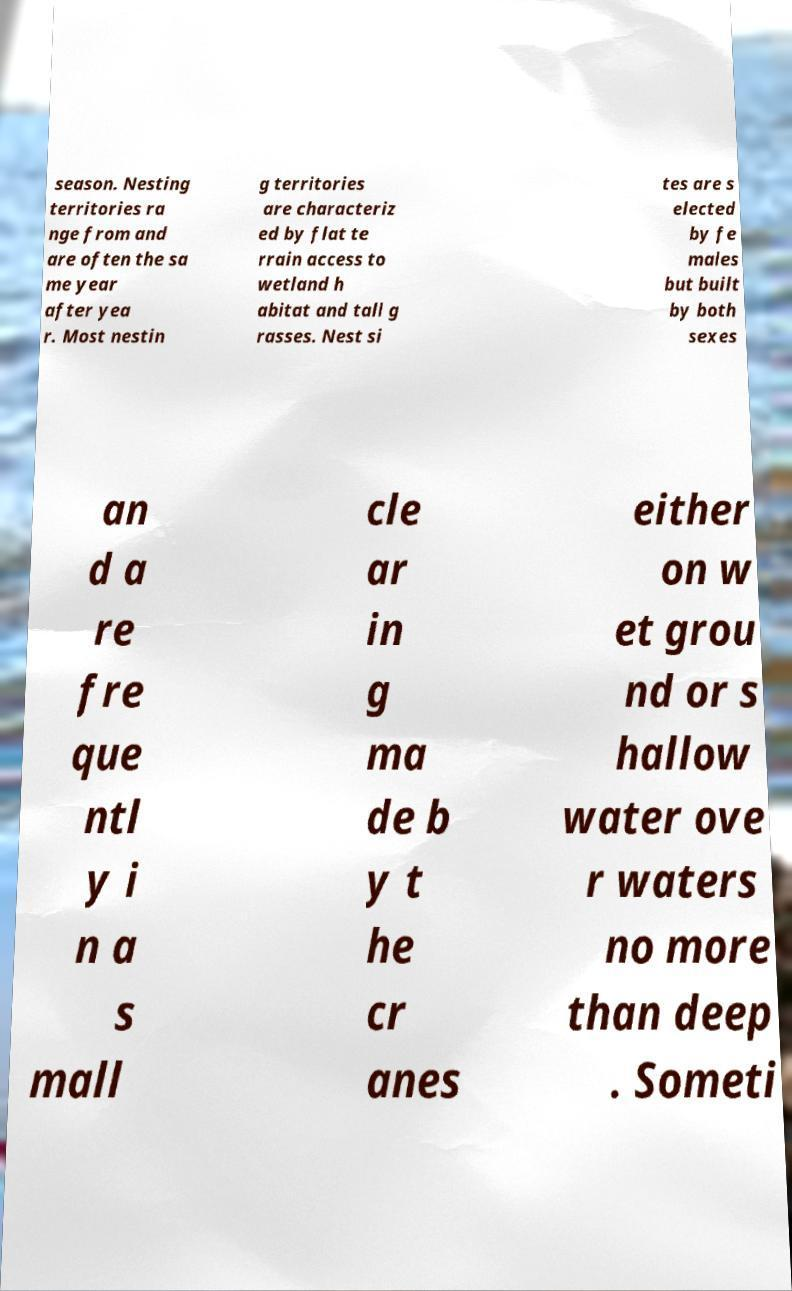What messages or text are displayed in this image? I need them in a readable, typed format. season. Nesting territories ra nge from and are often the sa me year after yea r. Most nestin g territories are characteriz ed by flat te rrain access to wetland h abitat and tall g rasses. Nest si tes are s elected by fe males but built by both sexes an d a re fre que ntl y i n a s mall cle ar in g ma de b y t he cr anes either on w et grou nd or s hallow water ove r waters no more than deep . Someti 